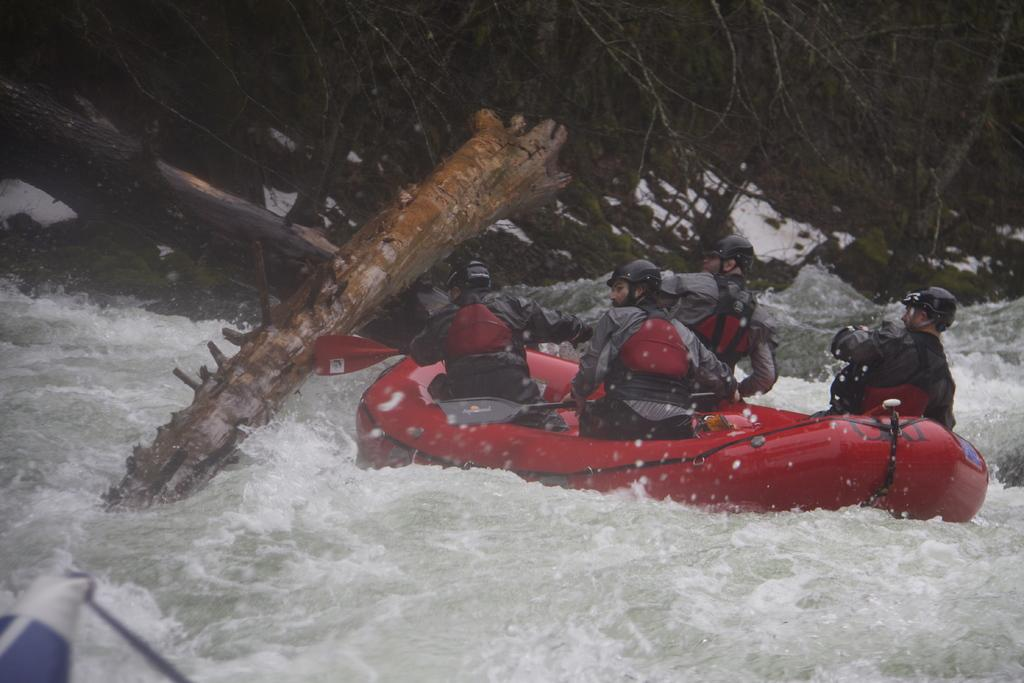What activity is taking place in the image? There is river rafting in the image. Who is participating in the activity? There are people on the raft. What can be seen on the raft? Tree barks are visible in the image. What is visible in the background of the image? There are trees in the background of the image. What type of board is being used for the river rafting in the image? There is no board visible in the image; the people are on a raft. 